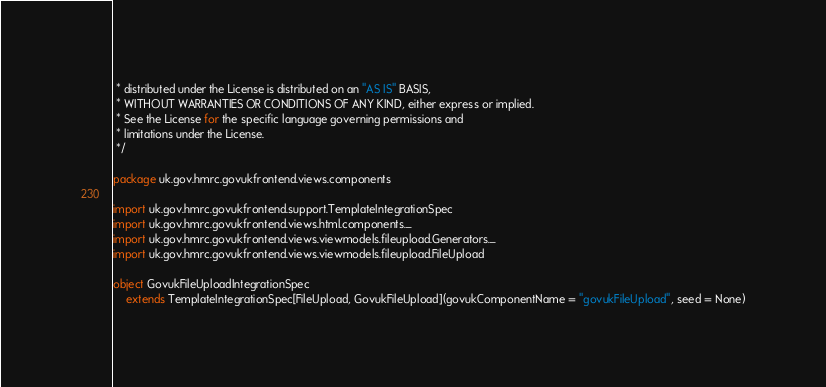Convert code to text. <code><loc_0><loc_0><loc_500><loc_500><_Scala_> * distributed under the License is distributed on an "AS IS" BASIS,
 * WITHOUT WARRANTIES OR CONDITIONS OF ANY KIND, either express or implied.
 * See the License for the specific language governing permissions and
 * limitations under the License.
 */

package uk.gov.hmrc.govukfrontend.views.components

import uk.gov.hmrc.govukfrontend.support.TemplateIntegrationSpec
import uk.gov.hmrc.govukfrontend.views.html.components._
import uk.gov.hmrc.govukfrontend.views.viewmodels.fileupload.Generators._
import uk.gov.hmrc.govukfrontend.views.viewmodels.fileupload.FileUpload

object GovukFileUploadIntegrationSpec
    extends TemplateIntegrationSpec[FileUpload, GovukFileUpload](govukComponentName = "govukFileUpload", seed = None)
</code> 